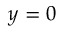Convert formula to latex. <formula><loc_0><loc_0><loc_500><loc_500>y = 0</formula> 